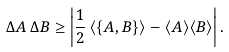Convert formula to latex. <formula><loc_0><loc_0><loc_500><loc_500>\Delta A \, \Delta B \geq \left | \frac { 1 } { 2 } \, \langle \{ A , B \} \rangle - \langle A \rangle \langle B \rangle \right | .</formula> 